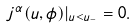Convert formula to latex. <formula><loc_0><loc_0><loc_500><loc_500>j ^ { \alpha } ( u , \phi ) | _ { u < u _ { - } } = 0 .</formula> 